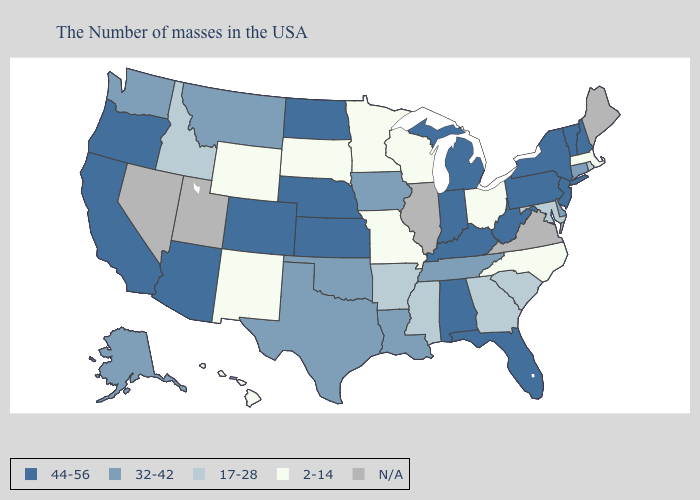What is the lowest value in states that border Missouri?
Answer briefly. 17-28. What is the lowest value in states that border Rhode Island?
Write a very short answer. 2-14. Does Oregon have the highest value in the West?
Concise answer only. Yes. What is the value of Idaho?
Write a very short answer. 17-28. What is the value of Arkansas?
Be succinct. 17-28. Does the first symbol in the legend represent the smallest category?
Short answer required. No. Name the states that have a value in the range 32-42?
Short answer required. Connecticut, Delaware, Tennessee, Louisiana, Iowa, Oklahoma, Texas, Montana, Washington, Alaska. Does Connecticut have the highest value in the USA?
Concise answer only. No. Name the states that have a value in the range 44-56?
Give a very brief answer. New Hampshire, Vermont, New York, New Jersey, Pennsylvania, West Virginia, Florida, Michigan, Kentucky, Indiana, Alabama, Kansas, Nebraska, North Dakota, Colorado, Arizona, California, Oregon. How many symbols are there in the legend?
Be succinct. 5. Name the states that have a value in the range 17-28?
Short answer required. Rhode Island, Maryland, South Carolina, Georgia, Mississippi, Arkansas, Idaho. Name the states that have a value in the range 32-42?
Write a very short answer. Connecticut, Delaware, Tennessee, Louisiana, Iowa, Oklahoma, Texas, Montana, Washington, Alaska. Which states have the lowest value in the MidWest?
Quick response, please. Ohio, Wisconsin, Missouri, Minnesota, South Dakota. Among the states that border Maine , which have the lowest value?
Concise answer only. New Hampshire. 